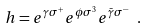<formula> <loc_0><loc_0><loc_500><loc_500>h = e ^ { \gamma \sigma ^ { + } } e ^ { \phi \sigma ^ { 3 } } e ^ { \bar { \gamma } \sigma ^ { - } } \ .</formula> 